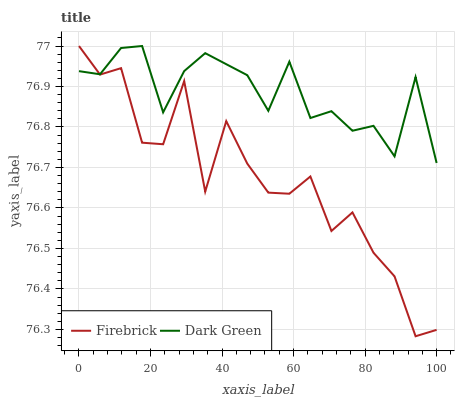Does Firebrick have the minimum area under the curve?
Answer yes or no. Yes. Does Dark Green have the maximum area under the curve?
Answer yes or no. Yes. Does Dark Green have the minimum area under the curve?
Answer yes or no. No. Is Dark Green the smoothest?
Answer yes or no. Yes. Is Firebrick the roughest?
Answer yes or no. Yes. Is Dark Green the roughest?
Answer yes or no. No. Does Firebrick have the lowest value?
Answer yes or no. Yes. Does Dark Green have the lowest value?
Answer yes or no. No. Does Dark Green have the highest value?
Answer yes or no. Yes. Does Dark Green intersect Firebrick?
Answer yes or no. Yes. Is Dark Green less than Firebrick?
Answer yes or no. No. Is Dark Green greater than Firebrick?
Answer yes or no. No. 